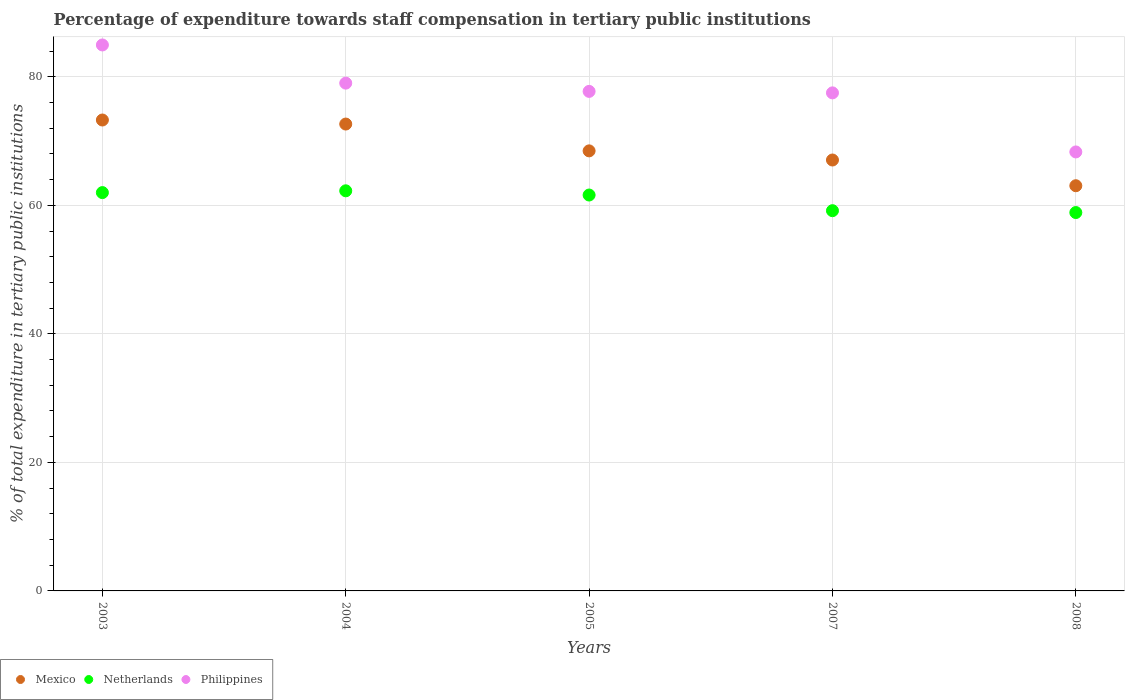Is the number of dotlines equal to the number of legend labels?
Keep it short and to the point. Yes. What is the percentage of expenditure towards staff compensation in Mexico in 2007?
Offer a very short reply. 67.05. Across all years, what is the maximum percentage of expenditure towards staff compensation in Netherlands?
Offer a terse response. 62.26. Across all years, what is the minimum percentage of expenditure towards staff compensation in Philippines?
Offer a very short reply. 68.31. In which year was the percentage of expenditure towards staff compensation in Netherlands maximum?
Provide a short and direct response. 2004. What is the total percentage of expenditure towards staff compensation in Mexico in the graph?
Your answer should be compact. 344.5. What is the difference between the percentage of expenditure towards staff compensation in Mexico in 2003 and that in 2007?
Your response must be concise. 6.22. What is the difference between the percentage of expenditure towards staff compensation in Mexico in 2007 and the percentage of expenditure towards staff compensation in Philippines in 2008?
Your answer should be compact. -1.26. What is the average percentage of expenditure towards staff compensation in Netherlands per year?
Your answer should be very brief. 60.78. In the year 2008, what is the difference between the percentage of expenditure towards staff compensation in Netherlands and percentage of expenditure towards staff compensation in Philippines?
Make the answer very short. -9.43. In how many years, is the percentage of expenditure towards staff compensation in Philippines greater than 48 %?
Your answer should be compact. 5. What is the ratio of the percentage of expenditure towards staff compensation in Mexico in 2005 to that in 2008?
Provide a short and direct response. 1.09. Is the percentage of expenditure towards staff compensation in Philippines in 2005 less than that in 2008?
Your answer should be compact. No. Is the difference between the percentage of expenditure towards staff compensation in Netherlands in 2004 and 2005 greater than the difference between the percentage of expenditure towards staff compensation in Philippines in 2004 and 2005?
Your answer should be compact. No. What is the difference between the highest and the second highest percentage of expenditure towards staff compensation in Netherlands?
Your answer should be very brief. 0.28. What is the difference between the highest and the lowest percentage of expenditure towards staff compensation in Mexico?
Your answer should be very brief. 10.23. Is the sum of the percentage of expenditure towards staff compensation in Netherlands in 2003 and 2007 greater than the maximum percentage of expenditure towards staff compensation in Philippines across all years?
Ensure brevity in your answer.  Yes. Is it the case that in every year, the sum of the percentage of expenditure towards staff compensation in Netherlands and percentage of expenditure towards staff compensation in Mexico  is greater than the percentage of expenditure towards staff compensation in Philippines?
Ensure brevity in your answer.  Yes. Is the percentage of expenditure towards staff compensation in Philippines strictly less than the percentage of expenditure towards staff compensation in Netherlands over the years?
Offer a terse response. No. Does the graph contain grids?
Give a very brief answer. Yes. What is the title of the graph?
Offer a very short reply. Percentage of expenditure towards staff compensation in tertiary public institutions. Does "Philippines" appear as one of the legend labels in the graph?
Offer a terse response. Yes. What is the label or title of the X-axis?
Keep it short and to the point. Years. What is the label or title of the Y-axis?
Make the answer very short. % of total expenditure in tertiary public institutions. What is the % of total expenditure in tertiary public institutions of Mexico in 2003?
Provide a short and direct response. 73.28. What is the % of total expenditure in tertiary public institutions of Netherlands in 2003?
Offer a very short reply. 61.98. What is the % of total expenditure in tertiary public institutions in Philippines in 2003?
Your answer should be compact. 84.95. What is the % of total expenditure in tertiary public institutions of Mexico in 2004?
Provide a short and direct response. 72.65. What is the % of total expenditure in tertiary public institutions of Netherlands in 2004?
Keep it short and to the point. 62.26. What is the % of total expenditure in tertiary public institutions in Philippines in 2004?
Offer a very short reply. 79.01. What is the % of total expenditure in tertiary public institutions of Mexico in 2005?
Your response must be concise. 68.47. What is the % of total expenditure in tertiary public institutions in Netherlands in 2005?
Provide a succinct answer. 61.6. What is the % of total expenditure in tertiary public institutions of Philippines in 2005?
Ensure brevity in your answer.  77.73. What is the % of total expenditure in tertiary public institutions in Mexico in 2007?
Keep it short and to the point. 67.05. What is the % of total expenditure in tertiary public institutions in Netherlands in 2007?
Provide a succinct answer. 59.17. What is the % of total expenditure in tertiary public institutions of Philippines in 2007?
Offer a very short reply. 77.5. What is the % of total expenditure in tertiary public institutions of Mexico in 2008?
Provide a succinct answer. 63.05. What is the % of total expenditure in tertiary public institutions of Netherlands in 2008?
Your response must be concise. 58.88. What is the % of total expenditure in tertiary public institutions in Philippines in 2008?
Your answer should be compact. 68.31. Across all years, what is the maximum % of total expenditure in tertiary public institutions in Mexico?
Offer a very short reply. 73.28. Across all years, what is the maximum % of total expenditure in tertiary public institutions of Netherlands?
Your response must be concise. 62.26. Across all years, what is the maximum % of total expenditure in tertiary public institutions in Philippines?
Give a very brief answer. 84.95. Across all years, what is the minimum % of total expenditure in tertiary public institutions in Mexico?
Offer a very short reply. 63.05. Across all years, what is the minimum % of total expenditure in tertiary public institutions in Netherlands?
Offer a terse response. 58.88. Across all years, what is the minimum % of total expenditure in tertiary public institutions in Philippines?
Give a very brief answer. 68.31. What is the total % of total expenditure in tertiary public institutions of Mexico in the graph?
Offer a terse response. 344.5. What is the total % of total expenditure in tertiary public institutions of Netherlands in the graph?
Make the answer very short. 303.88. What is the total % of total expenditure in tertiary public institutions in Philippines in the graph?
Make the answer very short. 387.5. What is the difference between the % of total expenditure in tertiary public institutions in Mexico in 2003 and that in 2004?
Ensure brevity in your answer.  0.63. What is the difference between the % of total expenditure in tertiary public institutions of Netherlands in 2003 and that in 2004?
Offer a terse response. -0.28. What is the difference between the % of total expenditure in tertiary public institutions in Philippines in 2003 and that in 2004?
Offer a very short reply. 5.94. What is the difference between the % of total expenditure in tertiary public institutions of Mexico in 2003 and that in 2005?
Ensure brevity in your answer.  4.8. What is the difference between the % of total expenditure in tertiary public institutions of Netherlands in 2003 and that in 2005?
Offer a very short reply. 0.38. What is the difference between the % of total expenditure in tertiary public institutions in Philippines in 2003 and that in 2005?
Give a very brief answer. 7.23. What is the difference between the % of total expenditure in tertiary public institutions of Mexico in 2003 and that in 2007?
Offer a terse response. 6.22. What is the difference between the % of total expenditure in tertiary public institutions in Netherlands in 2003 and that in 2007?
Provide a short and direct response. 2.81. What is the difference between the % of total expenditure in tertiary public institutions of Philippines in 2003 and that in 2007?
Provide a short and direct response. 7.46. What is the difference between the % of total expenditure in tertiary public institutions of Mexico in 2003 and that in 2008?
Your response must be concise. 10.23. What is the difference between the % of total expenditure in tertiary public institutions of Netherlands in 2003 and that in 2008?
Keep it short and to the point. 3.1. What is the difference between the % of total expenditure in tertiary public institutions of Philippines in 2003 and that in 2008?
Provide a succinct answer. 16.65. What is the difference between the % of total expenditure in tertiary public institutions in Mexico in 2004 and that in 2005?
Provide a succinct answer. 4.17. What is the difference between the % of total expenditure in tertiary public institutions of Netherlands in 2004 and that in 2005?
Offer a very short reply. 0.66. What is the difference between the % of total expenditure in tertiary public institutions in Philippines in 2004 and that in 2005?
Your response must be concise. 1.28. What is the difference between the % of total expenditure in tertiary public institutions in Mexico in 2004 and that in 2007?
Provide a succinct answer. 5.6. What is the difference between the % of total expenditure in tertiary public institutions of Netherlands in 2004 and that in 2007?
Provide a short and direct response. 3.09. What is the difference between the % of total expenditure in tertiary public institutions of Philippines in 2004 and that in 2007?
Provide a short and direct response. 1.52. What is the difference between the % of total expenditure in tertiary public institutions of Mexico in 2004 and that in 2008?
Your answer should be very brief. 9.6. What is the difference between the % of total expenditure in tertiary public institutions of Netherlands in 2004 and that in 2008?
Make the answer very short. 3.38. What is the difference between the % of total expenditure in tertiary public institutions in Philippines in 2004 and that in 2008?
Your response must be concise. 10.71. What is the difference between the % of total expenditure in tertiary public institutions of Mexico in 2005 and that in 2007?
Keep it short and to the point. 1.42. What is the difference between the % of total expenditure in tertiary public institutions of Netherlands in 2005 and that in 2007?
Make the answer very short. 2.44. What is the difference between the % of total expenditure in tertiary public institutions of Philippines in 2005 and that in 2007?
Give a very brief answer. 0.23. What is the difference between the % of total expenditure in tertiary public institutions in Mexico in 2005 and that in 2008?
Offer a terse response. 5.42. What is the difference between the % of total expenditure in tertiary public institutions in Netherlands in 2005 and that in 2008?
Keep it short and to the point. 2.73. What is the difference between the % of total expenditure in tertiary public institutions of Philippines in 2005 and that in 2008?
Offer a very short reply. 9.42. What is the difference between the % of total expenditure in tertiary public institutions in Mexico in 2007 and that in 2008?
Your answer should be very brief. 4. What is the difference between the % of total expenditure in tertiary public institutions in Netherlands in 2007 and that in 2008?
Make the answer very short. 0.29. What is the difference between the % of total expenditure in tertiary public institutions of Philippines in 2007 and that in 2008?
Your answer should be very brief. 9.19. What is the difference between the % of total expenditure in tertiary public institutions of Mexico in 2003 and the % of total expenditure in tertiary public institutions of Netherlands in 2004?
Offer a terse response. 11.02. What is the difference between the % of total expenditure in tertiary public institutions in Mexico in 2003 and the % of total expenditure in tertiary public institutions in Philippines in 2004?
Your response must be concise. -5.74. What is the difference between the % of total expenditure in tertiary public institutions of Netherlands in 2003 and the % of total expenditure in tertiary public institutions of Philippines in 2004?
Offer a very short reply. -17.03. What is the difference between the % of total expenditure in tertiary public institutions of Mexico in 2003 and the % of total expenditure in tertiary public institutions of Netherlands in 2005?
Keep it short and to the point. 11.67. What is the difference between the % of total expenditure in tertiary public institutions in Mexico in 2003 and the % of total expenditure in tertiary public institutions in Philippines in 2005?
Give a very brief answer. -4.45. What is the difference between the % of total expenditure in tertiary public institutions of Netherlands in 2003 and the % of total expenditure in tertiary public institutions of Philippines in 2005?
Ensure brevity in your answer.  -15.75. What is the difference between the % of total expenditure in tertiary public institutions of Mexico in 2003 and the % of total expenditure in tertiary public institutions of Netherlands in 2007?
Your response must be concise. 14.11. What is the difference between the % of total expenditure in tertiary public institutions of Mexico in 2003 and the % of total expenditure in tertiary public institutions of Philippines in 2007?
Provide a short and direct response. -4.22. What is the difference between the % of total expenditure in tertiary public institutions in Netherlands in 2003 and the % of total expenditure in tertiary public institutions in Philippines in 2007?
Offer a very short reply. -15.52. What is the difference between the % of total expenditure in tertiary public institutions of Mexico in 2003 and the % of total expenditure in tertiary public institutions of Netherlands in 2008?
Your answer should be very brief. 14.4. What is the difference between the % of total expenditure in tertiary public institutions of Mexico in 2003 and the % of total expenditure in tertiary public institutions of Philippines in 2008?
Your answer should be compact. 4.97. What is the difference between the % of total expenditure in tertiary public institutions in Netherlands in 2003 and the % of total expenditure in tertiary public institutions in Philippines in 2008?
Your answer should be very brief. -6.33. What is the difference between the % of total expenditure in tertiary public institutions in Mexico in 2004 and the % of total expenditure in tertiary public institutions in Netherlands in 2005?
Give a very brief answer. 11.04. What is the difference between the % of total expenditure in tertiary public institutions in Mexico in 2004 and the % of total expenditure in tertiary public institutions in Philippines in 2005?
Make the answer very short. -5.08. What is the difference between the % of total expenditure in tertiary public institutions in Netherlands in 2004 and the % of total expenditure in tertiary public institutions in Philippines in 2005?
Offer a very short reply. -15.47. What is the difference between the % of total expenditure in tertiary public institutions of Mexico in 2004 and the % of total expenditure in tertiary public institutions of Netherlands in 2007?
Make the answer very short. 13.48. What is the difference between the % of total expenditure in tertiary public institutions in Mexico in 2004 and the % of total expenditure in tertiary public institutions in Philippines in 2007?
Ensure brevity in your answer.  -4.85. What is the difference between the % of total expenditure in tertiary public institutions in Netherlands in 2004 and the % of total expenditure in tertiary public institutions in Philippines in 2007?
Provide a short and direct response. -15.24. What is the difference between the % of total expenditure in tertiary public institutions of Mexico in 2004 and the % of total expenditure in tertiary public institutions of Netherlands in 2008?
Keep it short and to the point. 13.77. What is the difference between the % of total expenditure in tertiary public institutions in Mexico in 2004 and the % of total expenditure in tertiary public institutions in Philippines in 2008?
Ensure brevity in your answer.  4.34. What is the difference between the % of total expenditure in tertiary public institutions in Netherlands in 2004 and the % of total expenditure in tertiary public institutions in Philippines in 2008?
Your response must be concise. -6.05. What is the difference between the % of total expenditure in tertiary public institutions of Mexico in 2005 and the % of total expenditure in tertiary public institutions of Netherlands in 2007?
Offer a terse response. 9.31. What is the difference between the % of total expenditure in tertiary public institutions of Mexico in 2005 and the % of total expenditure in tertiary public institutions of Philippines in 2007?
Your response must be concise. -9.02. What is the difference between the % of total expenditure in tertiary public institutions of Netherlands in 2005 and the % of total expenditure in tertiary public institutions of Philippines in 2007?
Offer a very short reply. -15.9. What is the difference between the % of total expenditure in tertiary public institutions in Mexico in 2005 and the % of total expenditure in tertiary public institutions in Netherlands in 2008?
Keep it short and to the point. 9.6. What is the difference between the % of total expenditure in tertiary public institutions in Mexico in 2005 and the % of total expenditure in tertiary public institutions in Philippines in 2008?
Make the answer very short. 0.17. What is the difference between the % of total expenditure in tertiary public institutions in Netherlands in 2005 and the % of total expenditure in tertiary public institutions in Philippines in 2008?
Your answer should be very brief. -6.7. What is the difference between the % of total expenditure in tertiary public institutions in Mexico in 2007 and the % of total expenditure in tertiary public institutions in Netherlands in 2008?
Your answer should be very brief. 8.17. What is the difference between the % of total expenditure in tertiary public institutions of Mexico in 2007 and the % of total expenditure in tertiary public institutions of Philippines in 2008?
Your response must be concise. -1.26. What is the difference between the % of total expenditure in tertiary public institutions in Netherlands in 2007 and the % of total expenditure in tertiary public institutions in Philippines in 2008?
Offer a terse response. -9.14. What is the average % of total expenditure in tertiary public institutions of Mexico per year?
Your answer should be very brief. 68.9. What is the average % of total expenditure in tertiary public institutions in Netherlands per year?
Give a very brief answer. 60.78. What is the average % of total expenditure in tertiary public institutions of Philippines per year?
Your response must be concise. 77.5. In the year 2003, what is the difference between the % of total expenditure in tertiary public institutions of Mexico and % of total expenditure in tertiary public institutions of Netherlands?
Offer a very short reply. 11.3. In the year 2003, what is the difference between the % of total expenditure in tertiary public institutions of Mexico and % of total expenditure in tertiary public institutions of Philippines?
Your response must be concise. -11.68. In the year 2003, what is the difference between the % of total expenditure in tertiary public institutions in Netherlands and % of total expenditure in tertiary public institutions in Philippines?
Your response must be concise. -22.97. In the year 2004, what is the difference between the % of total expenditure in tertiary public institutions of Mexico and % of total expenditure in tertiary public institutions of Netherlands?
Provide a short and direct response. 10.39. In the year 2004, what is the difference between the % of total expenditure in tertiary public institutions of Mexico and % of total expenditure in tertiary public institutions of Philippines?
Offer a very short reply. -6.37. In the year 2004, what is the difference between the % of total expenditure in tertiary public institutions in Netherlands and % of total expenditure in tertiary public institutions in Philippines?
Your answer should be very brief. -16.75. In the year 2005, what is the difference between the % of total expenditure in tertiary public institutions in Mexico and % of total expenditure in tertiary public institutions in Netherlands?
Make the answer very short. 6.87. In the year 2005, what is the difference between the % of total expenditure in tertiary public institutions in Mexico and % of total expenditure in tertiary public institutions in Philippines?
Offer a terse response. -9.26. In the year 2005, what is the difference between the % of total expenditure in tertiary public institutions of Netherlands and % of total expenditure in tertiary public institutions of Philippines?
Give a very brief answer. -16.13. In the year 2007, what is the difference between the % of total expenditure in tertiary public institutions of Mexico and % of total expenditure in tertiary public institutions of Netherlands?
Your answer should be very brief. 7.89. In the year 2007, what is the difference between the % of total expenditure in tertiary public institutions in Mexico and % of total expenditure in tertiary public institutions in Philippines?
Provide a succinct answer. -10.45. In the year 2007, what is the difference between the % of total expenditure in tertiary public institutions of Netherlands and % of total expenditure in tertiary public institutions of Philippines?
Provide a short and direct response. -18.33. In the year 2008, what is the difference between the % of total expenditure in tertiary public institutions of Mexico and % of total expenditure in tertiary public institutions of Netherlands?
Give a very brief answer. 4.17. In the year 2008, what is the difference between the % of total expenditure in tertiary public institutions in Mexico and % of total expenditure in tertiary public institutions in Philippines?
Give a very brief answer. -5.26. In the year 2008, what is the difference between the % of total expenditure in tertiary public institutions in Netherlands and % of total expenditure in tertiary public institutions in Philippines?
Your answer should be very brief. -9.43. What is the ratio of the % of total expenditure in tertiary public institutions in Mexico in 2003 to that in 2004?
Make the answer very short. 1.01. What is the ratio of the % of total expenditure in tertiary public institutions in Philippines in 2003 to that in 2004?
Provide a short and direct response. 1.08. What is the ratio of the % of total expenditure in tertiary public institutions in Mexico in 2003 to that in 2005?
Make the answer very short. 1.07. What is the ratio of the % of total expenditure in tertiary public institutions in Netherlands in 2003 to that in 2005?
Your answer should be compact. 1.01. What is the ratio of the % of total expenditure in tertiary public institutions of Philippines in 2003 to that in 2005?
Make the answer very short. 1.09. What is the ratio of the % of total expenditure in tertiary public institutions in Mexico in 2003 to that in 2007?
Offer a very short reply. 1.09. What is the ratio of the % of total expenditure in tertiary public institutions of Netherlands in 2003 to that in 2007?
Ensure brevity in your answer.  1.05. What is the ratio of the % of total expenditure in tertiary public institutions in Philippines in 2003 to that in 2007?
Your answer should be compact. 1.1. What is the ratio of the % of total expenditure in tertiary public institutions of Mexico in 2003 to that in 2008?
Provide a succinct answer. 1.16. What is the ratio of the % of total expenditure in tertiary public institutions in Netherlands in 2003 to that in 2008?
Provide a succinct answer. 1.05. What is the ratio of the % of total expenditure in tertiary public institutions in Philippines in 2003 to that in 2008?
Your answer should be very brief. 1.24. What is the ratio of the % of total expenditure in tertiary public institutions of Mexico in 2004 to that in 2005?
Your response must be concise. 1.06. What is the ratio of the % of total expenditure in tertiary public institutions of Netherlands in 2004 to that in 2005?
Offer a terse response. 1.01. What is the ratio of the % of total expenditure in tertiary public institutions of Philippines in 2004 to that in 2005?
Provide a short and direct response. 1.02. What is the ratio of the % of total expenditure in tertiary public institutions of Mexico in 2004 to that in 2007?
Provide a succinct answer. 1.08. What is the ratio of the % of total expenditure in tertiary public institutions of Netherlands in 2004 to that in 2007?
Provide a short and direct response. 1.05. What is the ratio of the % of total expenditure in tertiary public institutions of Philippines in 2004 to that in 2007?
Your response must be concise. 1.02. What is the ratio of the % of total expenditure in tertiary public institutions of Mexico in 2004 to that in 2008?
Keep it short and to the point. 1.15. What is the ratio of the % of total expenditure in tertiary public institutions in Netherlands in 2004 to that in 2008?
Keep it short and to the point. 1.06. What is the ratio of the % of total expenditure in tertiary public institutions of Philippines in 2004 to that in 2008?
Ensure brevity in your answer.  1.16. What is the ratio of the % of total expenditure in tertiary public institutions in Mexico in 2005 to that in 2007?
Your answer should be compact. 1.02. What is the ratio of the % of total expenditure in tertiary public institutions in Netherlands in 2005 to that in 2007?
Make the answer very short. 1.04. What is the ratio of the % of total expenditure in tertiary public institutions in Mexico in 2005 to that in 2008?
Your answer should be very brief. 1.09. What is the ratio of the % of total expenditure in tertiary public institutions of Netherlands in 2005 to that in 2008?
Ensure brevity in your answer.  1.05. What is the ratio of the % of total expenditure in tertiary public institutions of Philippines in 2005 to that in 2008?
Provide a short and direct response. 1.14. What is the ratio of the % of total expenditure in tertiary public institutions of Mexico in 2007 to that in 2008?
Your answer should be compact. 1.06. What is the ratio of the % of total expenditure in tertiary public institutions of Philippines in 2007 to that in 2008?
Make the answer very short. 1.13. What is the difference between the highest and the second highest % of total expenditure in tertiary public institutions in Mexico?
Give a very brief answer. 0.63. What is the difference between the highest and the second highest % of total expenditure in tertiary public institutions of Netherlands?
Your response must be concise. 0.28. What is the difference between the highest and the second highest % of total expenditure in tertiary public institutions in Philippines?
Make the answer very short. 5.94. What is the difference between the highest and the lowest % of total expenditure in tertiary public institutions in Mexico?
Offer a very short reply. 10.23. What is the difference between the highest and the lowest % of total expenditure in tertiary public institutions in Netherlands?
Provide a short and direct response. 3.38. What is the difference between the highest and the lowest % of total expenditure in tertiary public institutions in Philippines?
Give a very brief answer. 16.65. 